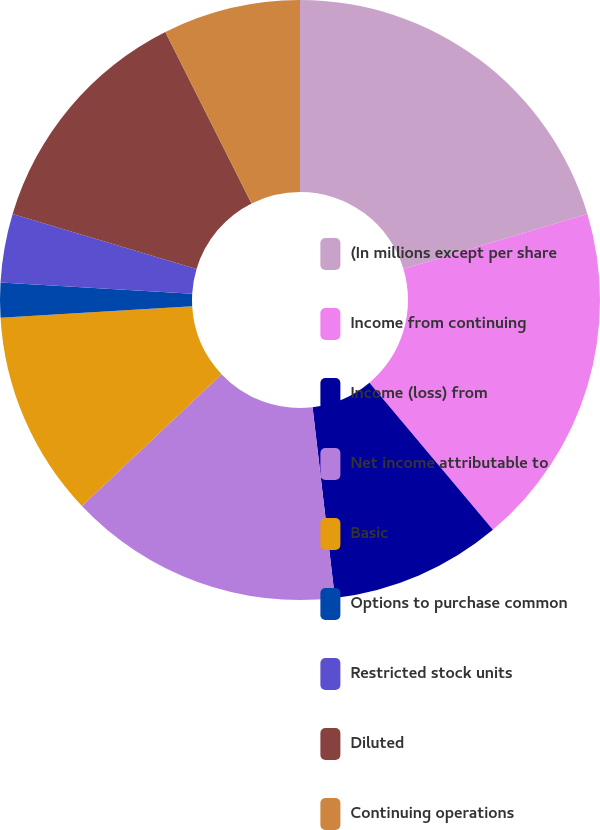Convert chart. <chart><loc_0><loc_0><loc_500><loc_500><pie_chart><fcel>(In millions except per share<fcel>Income from continuing<fcel>Income (loss) from<fcel>Net income attributable to<fcel>Basic<fcel>Options to purchase common<fcel>Restricted stock units<fcel>Diluted<fcel>Continuing operations<nl><fcel>20.37%<fcel>18.52%<fcel>9.26%<fcel>14.81%<fcel>11.11%<fcel>1.86%<fcel>3.71%<fcel>12.96%<fcel>7.41%<nl></chart> 